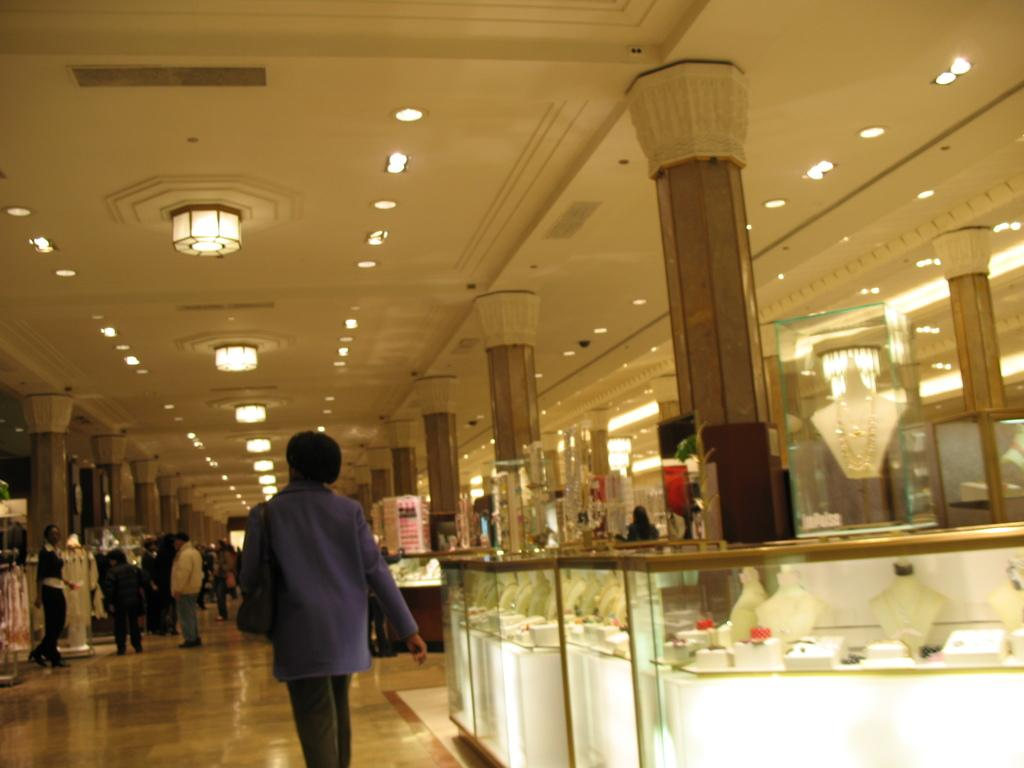What can be seen in the image? There are people standing in the image. Where are the people standing? The people are standing on the floor. What is on the right side of the image? There is a shelf with jewellery on the right side of the image. What can be seen on the ceiling in the image? Lights are fixed to the ceiling in the image. How many horses can be seen running on the road in the image? There are no horses or roads present in the image; it features people standing on the floor with a shelf of jewellery and lights on the ceiling. 